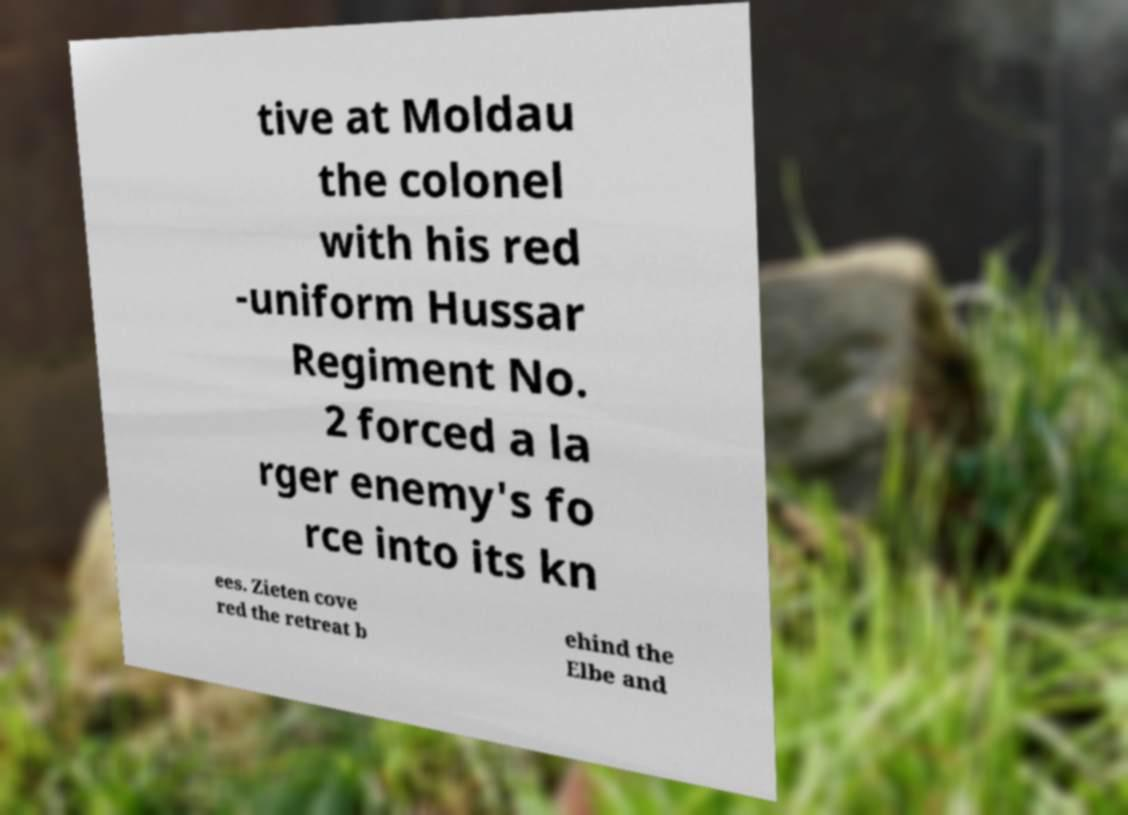I need the written content from this picture converted into text. Can you do that? tive at Moldau the colonel with his red -uniform Hussar Regiment No. 2 forced a la rger enemy's fo rce into its kn ees. Zieten cove red the retreat b ehind the Elbe and 